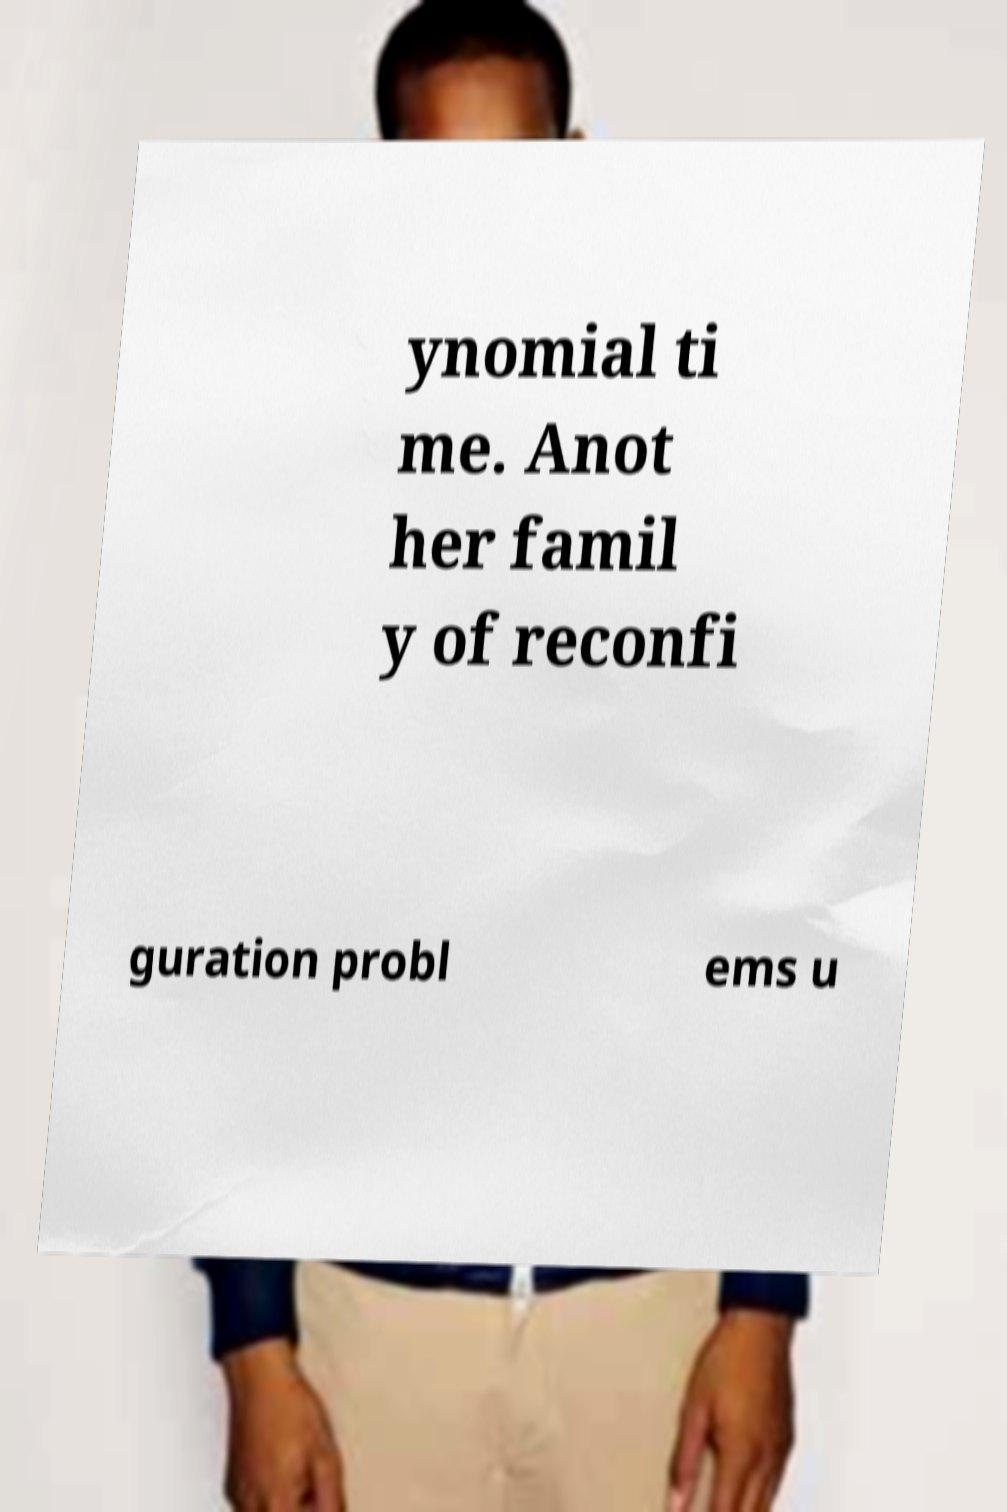Please read and relay the text visible in this image. What does it say? ynomial ti me. Anot her famil y of reconfi guration probl ems u 